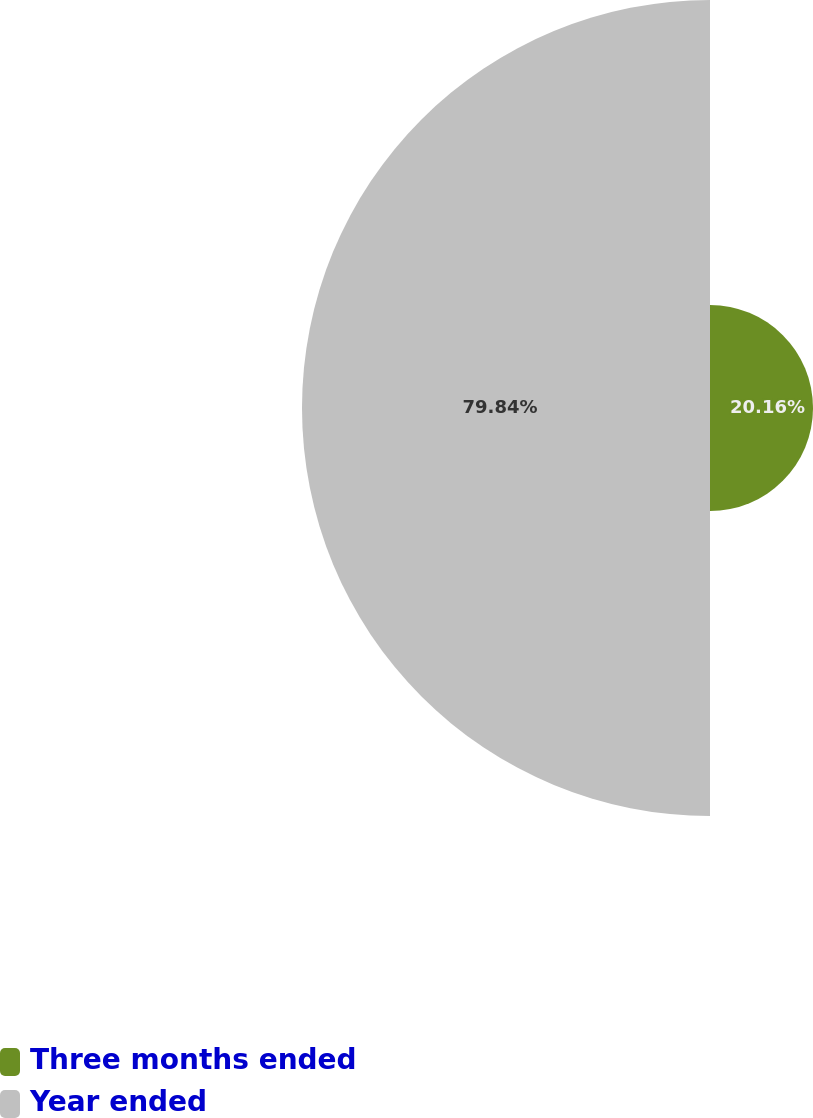Convert chart to OTSL. <chart><loc_0><loc_0><loc_500><loc_500><pie_chart><fcel>Three months ended<fcel>Year ended<nl><fcel>20.16%<fcel>79.84%<nl></chart> 